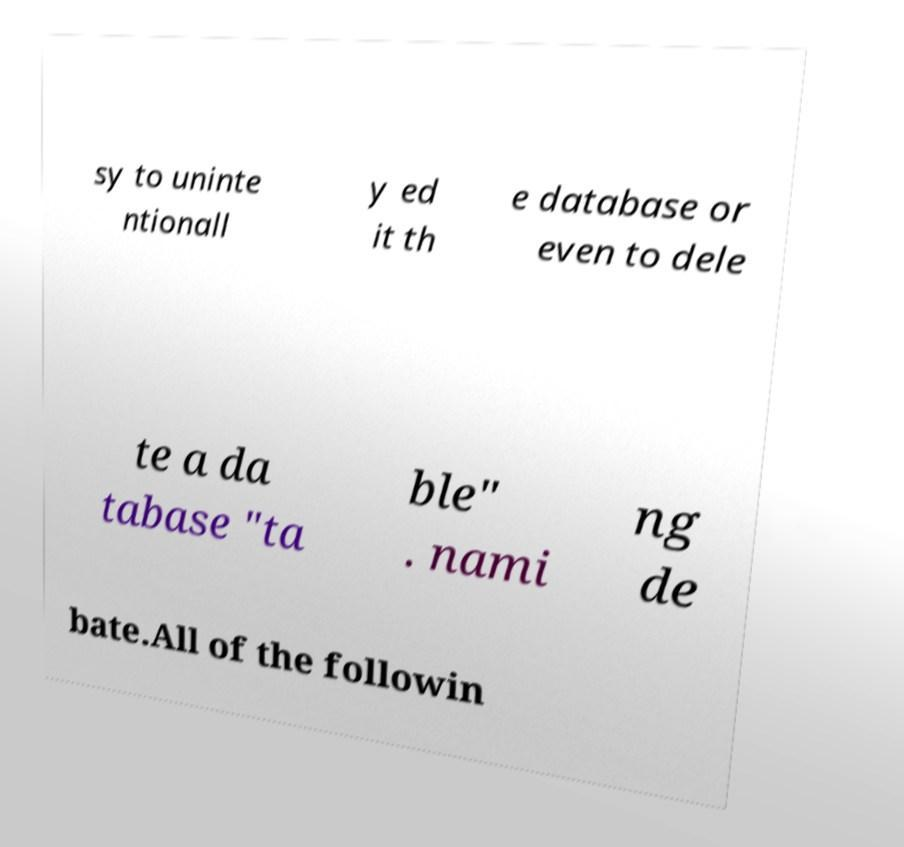What messages or text are displayed in this image? I need them in a readable, typed format. sy to uninte ntionall y ed it th e database or even to dele te a da tabase "ta ble" . nami ng de bate.All of the followin 